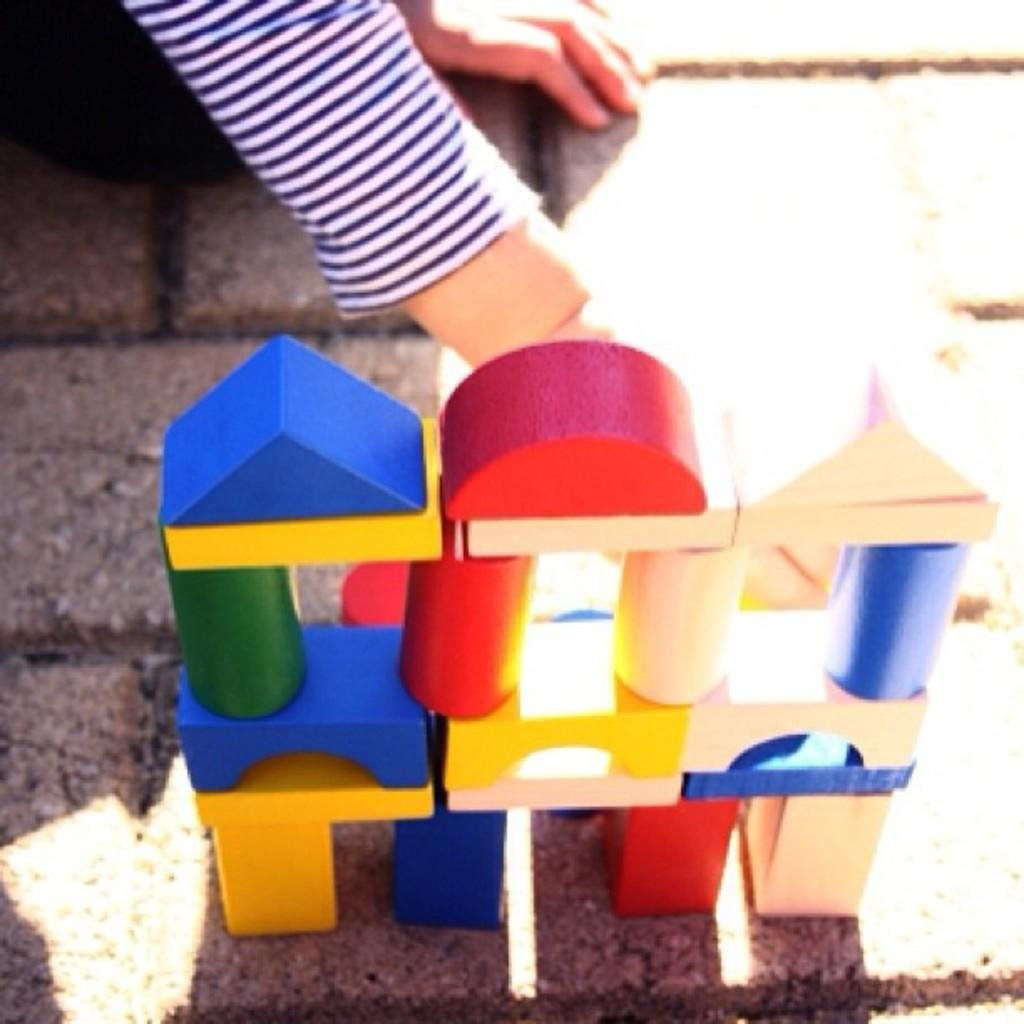What part of a person is visible in the image? There is a person's hand in the image. What is the hand doing in the image? The hand is touching toys. Where are the toys located in the image? The toys are on the land. What is the person's belief about the toys in the image? The image does not provide any information about the person's beliefs, so we cannot determine their belief about the toys. 